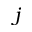Convert formula to latex. <formula><loc_0><loc_0><loc_500><loc_500>j</formula> 